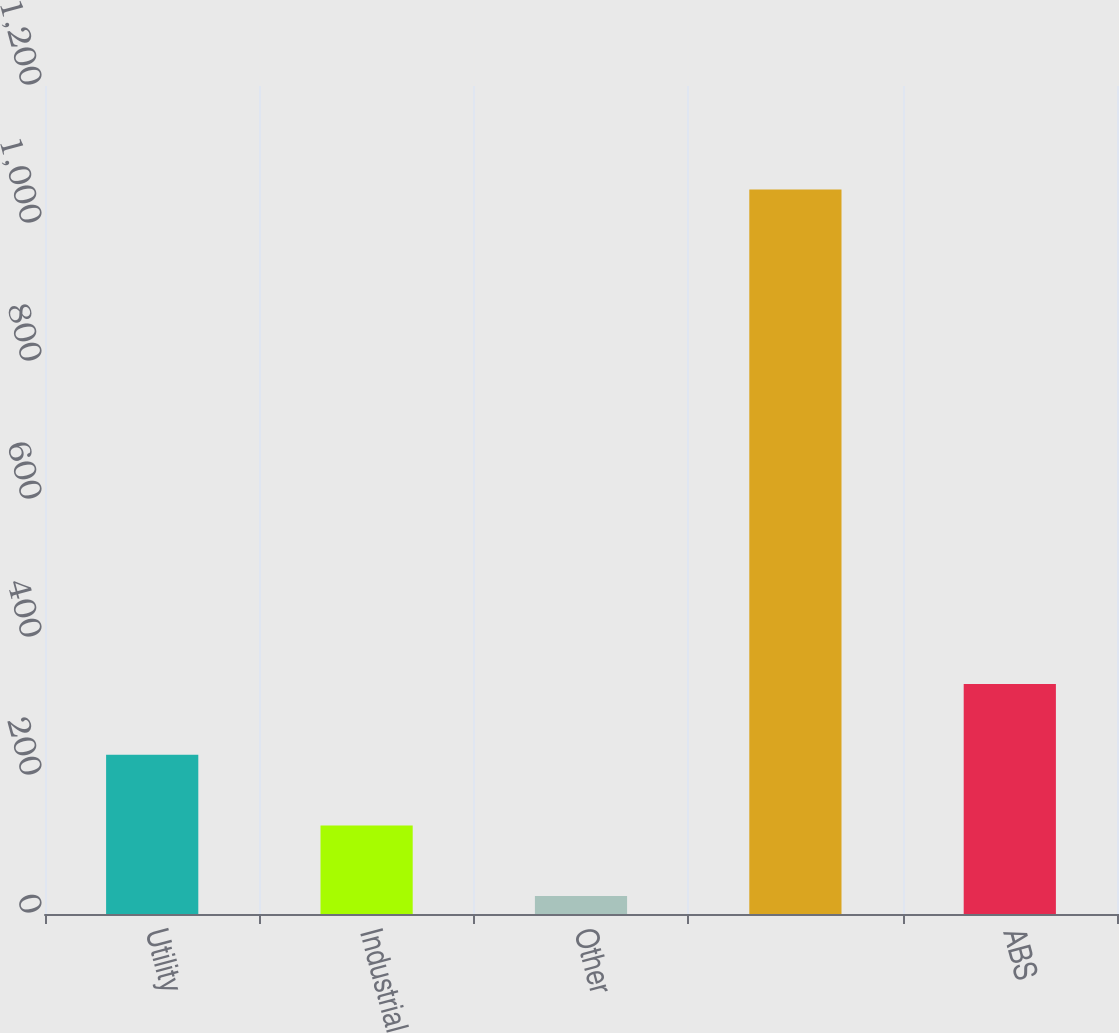<chart> <loc_0><loc_0><loc_500><loc_500><bar_chart><fcel>Utility<fcel>Industrial<fcel>Other<fcel>Unnamed: 3<fcel>ABS<nl><fcel>230.8<fcel>128.4<fcel>26<fcel>1050<fcel>333.2<nl></chart> 